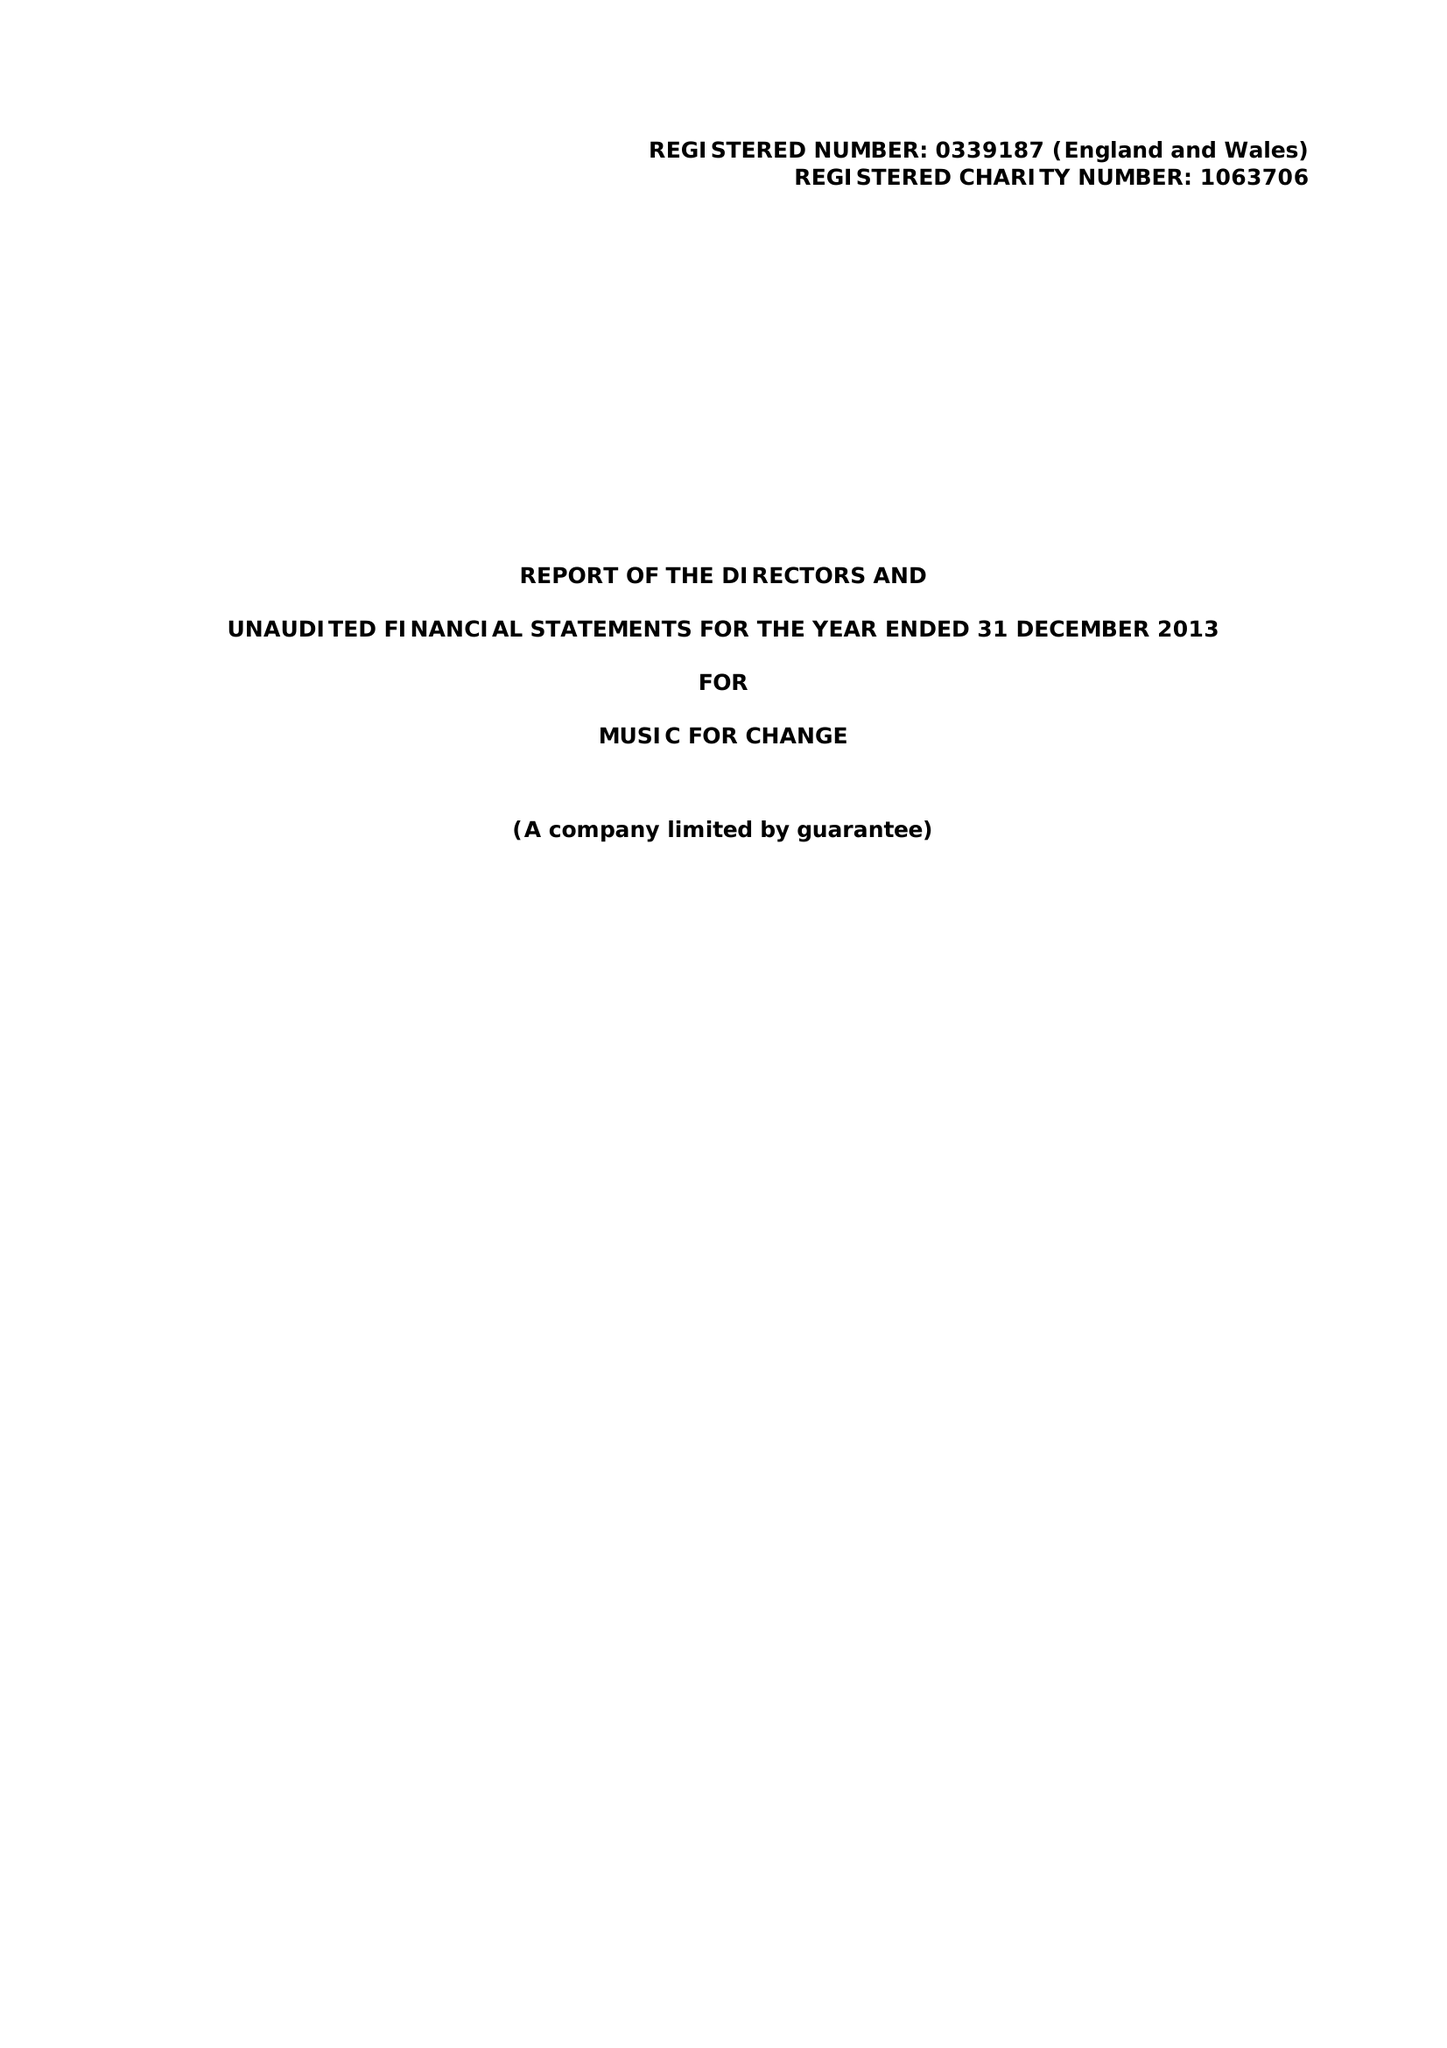What is the value for the address__street_line?
Answer the question using a single word or phrase. 77 STOUR STREET 